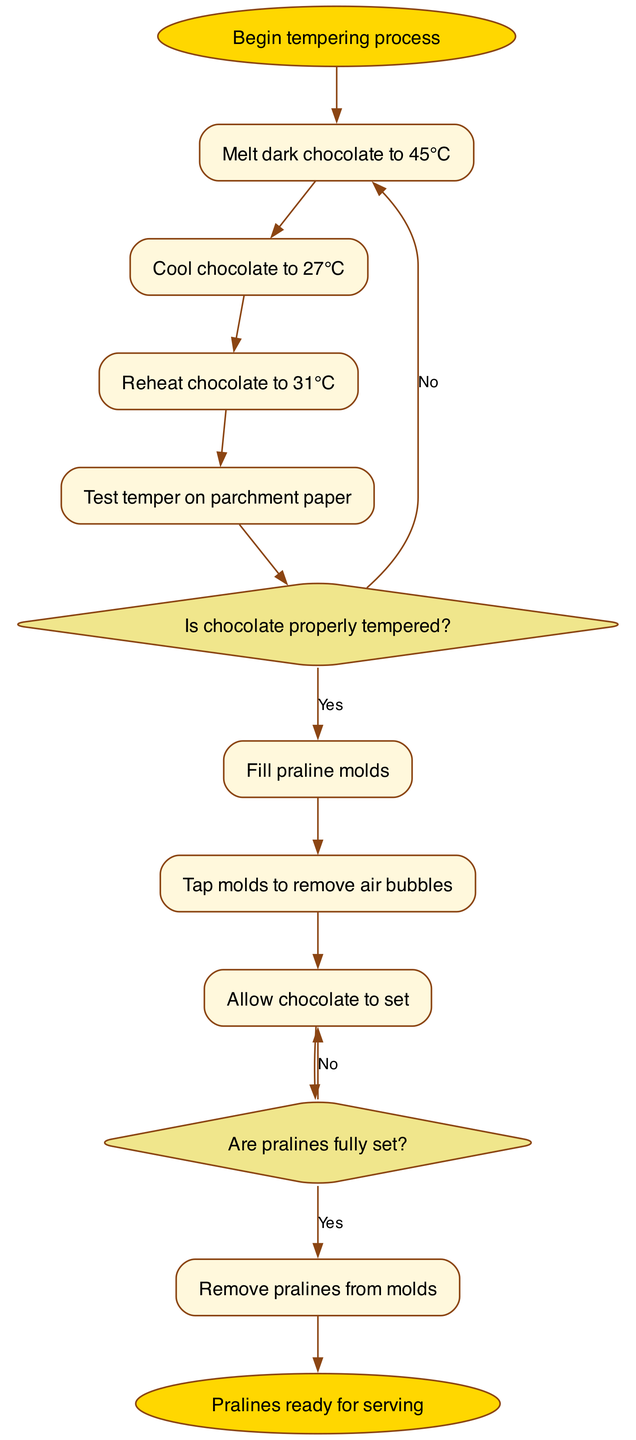What is the first step in the tempering process? The first step is described as "Melt dark chocolate to 45°C," which is indicated as the initial node connected to the start node.
Answer: Melt dark chocolate to 45°C How many decision nodes are present in the flowchart? There are two decision nodes, which are related to checking if chocolate is properly tempered and if pralines are fully set.
Answer: 2 What happens if the chocolate is not properly tempered? If the chocolate is not properly tempered, the flowchart indicates to "Repeat tempering process," which is the alternative path from the first decision node.
Answer: Repeat tempering process What temperature should the chocolate be reheated to? The reheating temperature specified in the diagram is 31°C, which is part of the sequential nodes after cooling down.
Answer: 31°C How many total nodes are there in this flowchart? The total number of nodes includes process and decision nodes, which adds up to eight; seven process nodes and two decision nodes, plus one start and one end node.
Answer: 10 What do you do if the pralines are not fully set? If the pralines are not fully set, the flowchart states to "Allow more setting time," which is the alternative path from the second decision node.
Answer: Allow more setting time What is the final outcome if all steps are completed successfully? The final outcome is indicated at the end node of the flowchart, stated as "Pralines ready for serving," which occurs after all conditions are met sequentially.
Answer: Pralines ready for serving After filling the praline molds, what must be done next? The next step after filling the praline molds is to "Tap molds to remove air bubbles," indicated in the flowchart as the subsequent process node.
Answer: Tap molds to remove air bubbles 